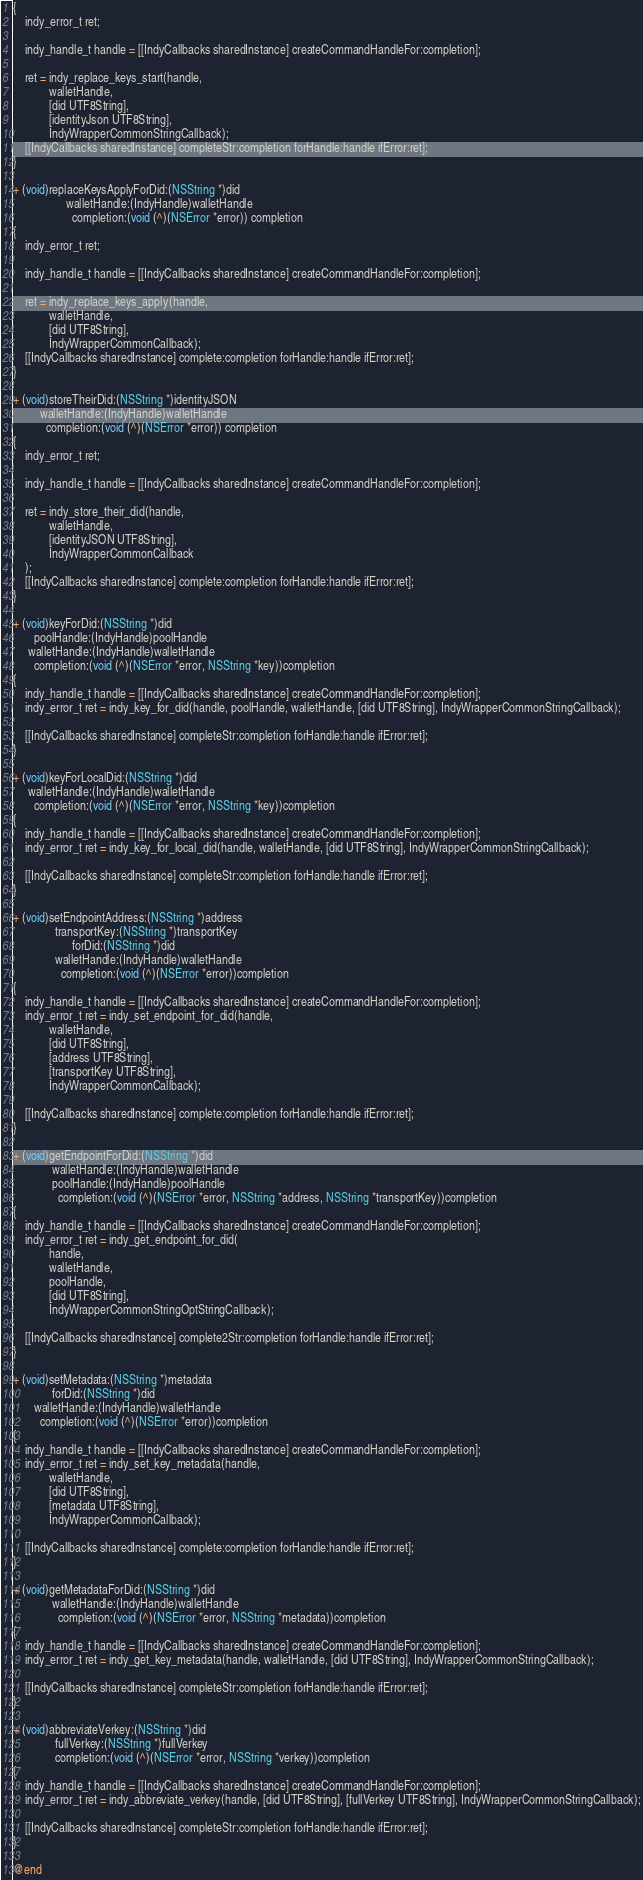Convert code to text. <code><loc_0><loc_0><loc_500><loc_500><_ObjectiveC_>{
    indy_error_t ret;
    
    indy_handle_t handle = [[IndyCallbacks sharedInstance] createCommandHandleFor:completion];
    
    ret = indy_replace_keys_start(handle,
            walletHandle,
            [did UTF8String],
            [identityJson UTF8String],
            IndyWrapperCommonStringCallback);
    [[IndyCallbacks sharedInstance] completeStr:completion forHandle:handle ifError:ret];
}

+ (void)replaceKeysApplyForDid:(NSString *)did
                  walletHandle:(IndyHandle)walletHandle
                    completion:(void (^)(NSError *error)) completion
{
    indy_error_t ret;
    
    indy_handle_t handle = [[IndyCallbacks sharedInstance] createCommandHandleFor:completion];
    
    ret = indy_replace_keys_apply(handle,
            walletHandle,
            [did UTF8String],
            IndyWrapperCommonCallback);
    [[IndyCallbacks sharedInstance] complete:completion forHandle:handle ifError:ret];
}

+ (void)storeTheirDid:(NSString *)identityJSON
         walletHandle:(IndyHandle)walletHandle
           completion:(void (^)(NSError *error)) completion
{
    indy_error_t ret;
    
    indy_handle_t handle = [[IndyCallbacks sharedInstance] createCommandHandleFor:completion];
    
    ret = indy_store_their_did(handle,
            walletHandle,
            [identityJSON UTF8String],
            IndyWrapperCommonCallback
    );
    [[IndyCallbacks sharedInstance] complete:completion forHandle:handle ifError:ret];
}

+ (void)keyForDid:(NSString *)did
       poolHandle:(IndyHandle)poolHandle
     walletHandle:(IndyHandle)walletHandle
       completion:(void (^)(NSError *error, NSString *key))completion
{
    indy_handle_t handle = [[IndyCallbacks sharedInstance] createCommandHandleFor:completion];
    indy_error_t ret = indy_key_for_did(handle, poolHandle, walletHandle, [did UTF8String], IndyWrapperCommonStringCallback);

    [[IndyCallbacks sharedInstance] completeStr:completion forHandle:handle ifError:ret];
}

+ (void)keyForLocalDid:(NSString *)did
     walletHandle:(IndyHandle)walletHandle
       completion:(void (^)(NSError *error, NSString *key))completion
{
    indy_handle_t handle = [[IndyCallbacks sharedInstance] createCommandHandleFor:completion];
    indy_error_t ret = indy_key_for_local_did(handle, walletHandle, [did UTF8String], IndyWrapperCommonStringCallback);

    [[IndyCallbacks sharedInstance] completeStr:completion forHandle:handle ifError:ret];
}

+ (void)setEndpointAddress:(NSString *)address
              transportKey:(NSString *)transportKey
                    forDid:(NSString *)did
              walletHandle:(IndyHandle)walletHandle
                completion:(void (^)(NSError *error))completion
{
    indy_handle_t handle = [[IndyCallbacks sharedInstance] createCommandHandleFor:completion];
    indy_error_t ret = indy_set_endpoint_for_did(handle,
            walletHandle,
            [did UTF8String],
            [address UTF8String],
            [transportKey UTF8String],
            IndyWrapperCommonCallback);

    [[IndyCallbacks sharedInstance] complete:completion forHandle:handle ifError:ret];
}

+ (void)getEndpointForDid:(NSString *)did
             walletHandle:(IndyHandle)walletHandle
             poolHandle:(IndyHandle)poolHandle
               completion:(void (^)(NSError *error, NSString *address, NSString *transportKey))completion
{
    indy_handle_t handle = [[IndyCallbacks sharedInstance] createCommandHandleFor:completion];
    indy_error_t ret = indy_get_endpoint_for_did(
            handle,
            walletHandle,
            poolHandle,
            [did UTF8String],
            IndyWrapperCommonStringOptStringCallback);

    [[IndyCallbacks sharedInstance] complete2Str:completion forHandle:handle ifError:ret];
}

+ (void)setMetadata:(NSString *)metadata
             forDid:(NSString *)did
       walletHandle:(IndyHandle)walletHandle
         completion:(void (^)(NSError *error))completion
{
    indy_handle_t handle = [[IndyCallbacks sharedInstance] createCommandHandleFor:completion];
    indy_error_t ret = indy_set_key_metadata(handle,
            walletHandle,
            [did UTF8String],
            [metadata UTF8String],
            IndyWrapperCommonCallback);

    [[IndyCallbacks sharedInstance] complete:completion forHandle:handle ifError:ret];
}

+ (void)getMetadataForDid:(NSString *)did
             walletHandle:(IndyHandle)walletHandle
               completion:(void (^)(NSError *error, NSString *metadata))completion
{
    indy_handle_t handle = [[IndyCallbacks sharedInstance] createCommandHandleFor:completion];
    indy_error_t ret = indy_get_key_metadata(handle, walletHandle, [did UTF8String], IndyWrapperCommonStringCallback);

    [[IndyCallbacks sharedInstance] completeStr:completion forHandle:handle ifError:ret];
}

+ (void)abbreviateVerkey:(NSString *)did
              fullVerkey:(NSString *)fullVerkey
              completion:(void (^)(NSError *error, NSString *verkey))completion
{
    indy_handle_t handle = [[IndyCallbacks sharedInstance] createCommandHandleFor:completion];
    indy_error_t ret = indy_abbreviate_verkey(handle, [did UTF8String], [fullVerkey UTF8String], IndyWrapperCommonStringCallback);

    [[IndyCallbacks sharedInstance] completeStr:completion forHandle:handle ifError:ret];
}

@end
</code> 